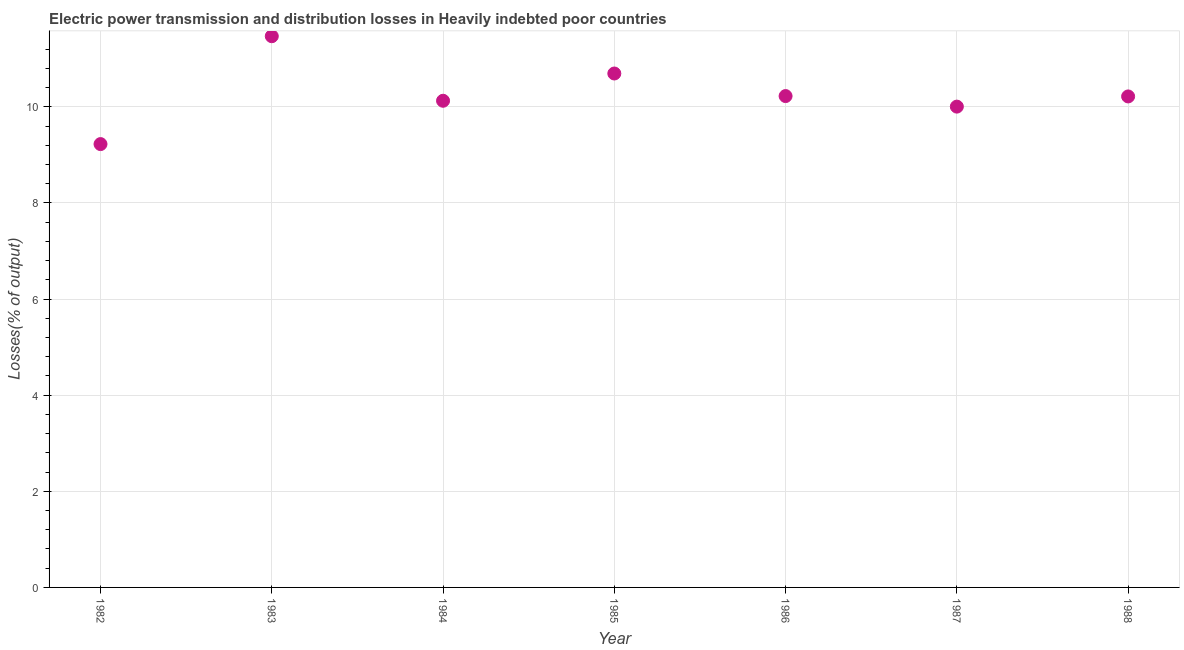What is the electric power transmission and distribution losses in 1988?
Ensure brevity in your answer.  10.22. Across all years, what is the maximum electric power transmission and distribution losses?
Your response must be concise. 11.47. Across all years, what is the minimum electric power transmission and distribution losses?
Your answer should be very brief. 9.23. In which year was the electric power transmission and distribution losses minimum?
Your answer should be compact. 1982. What is the sum of the electric power transmission and distribution losses?
Offer a very short reply. 71.96. What is the difference between the electric power transmission and distribution losses in 1986 and 1987?
Your answer should be very brief. 0.22. What is the average electric power transmission and distribution losses per year?
Offer a very short reply. 10.28. What is the median electric power transmission and distribution losses?
Your answer should be very brief. 10.22. In how many years, is the electric power transmission and distribution losses greater than 9.6 %?
Make the answer very short. 6. What is the ratio of the electric power transmission and distribution losses in 1982 to that in 1986?
Your answer should be very brief. 0.9. Is the difference between the electric power transmission and distribution losses in 1984 and 1988 greater than the difference between any two years?
Give a very brief answer. No. What is the difference between the highest and the second highest electric power transmission and distribution losses?
Provide a succinct answer. 0.78. Is the sum of the electric power transmission and distribution losses in 1983 and 1987 greater than the maximum electric power transmission and distribution losses across all years?
Offer a very short reply. Yes. What is the difference between the highest and the lowest electric power transmission and distribution losses?
Provide a succinct answer. 2.24. Does the electric power transmission and distribution losses monotonically increase over the years?
Your answer should be compact. No. How many dotlines are there?
Make the answer very short. 1. How many years are there in the graph?
Provide a succinct answer. 7. Are the values on the major ticks of Y-axis written in scientific E-notation?
Ensure brevity in your answer.  No. Does the graph contain any zero values?
Keep it short and to the point. No. Does the graph contain grids?
Your answer should be compact. Yes. What is the title of the graph?
Give a very brief answer. Electric power transmission and distribution losses in Heavily indebted poor countries. What is the label or title of the X-axis?
Give a very brief answer. Year. What is the label or title of the Y-axis?
Provide a succinct answer. Losses(% of output). What is the Losses(% of output) in 1982?
Make the answer very short. 9.23. What is the Losses(% of output) in 1983?
Offer a terse response. 11.47. What is the Losses(% of output) in 1984?
Your response must be concise. 10.13. What is the Losses(% of output) in 1985?
Ensure brevity in your answer.  10.69. What is the Losses(% of output) in 1986?
Offer a very short reply. 10.22. What is the Losses(% of output) in 1987?
Make the answer very short. 10. What is the Losses(% of output) in 1988?
Your response must be concise. 10.22. What is the difference between the Losses(% of output) in 1982 and 1983?
Provide a short and direct response. -2.24. What is the difference between the Losses(% of output) in 1982 and 1984?
Provide a short and direct response. -0.9. What is the difference between the Losses(% of output) in 1982 and 1985?
Offer a very short reply. -1.47. What is the difference between the Losses(% of output) in 1982 and 1986?
Provide a short and direct response. -1. What is the difference between the Losses(% of output) in 1982 and 1987?
Provide a short and direct response. -0.78. What is the difference between the Losses(% of output) in 1982 and 1988?
Keep it short and to the point. -0.99. What is the difference between the Losses(% of output) in 1983 and 1984?
Your answer should be very brief. 1.34. What is the difference between the Losses(% of output) in 1983 and 1985?
Give a very brief answer. 0.78. What is the difference between the Losses(% of output) in 1983 and 1986?
Provide a short and direct response. 1.25. What is the difference between the Losses(% of output) in 1983 and 1987?
Your response must be concise. 1.46. What is the difference between the Losses(% of output) in 1983 and 1988?
Your answer should be very brief. 1.25. What is the difference between the Losses(% of output) in 1984 and 1985?
Ensure brevity in your answer.  -0.57. What is the difference between the Losses(% of output) in 1984 and 1986?
Your answer should be compact. -0.1. What is the difference between the Losses(% of output) in 1984 and 1987?
Provide a succinct answer. 0.12. What is the difference between the Losses(% of output) in 1984 and 1988?
Offer a very short reply. -0.09. What is the difference between the Losses(% of output) in 1985 and 1986?
Ensure brevity in your answer.  0.47. What is the difference between the Losses(% of output) in 1985 and 1987?
Your response must be concise. 0.69. What is the difference between the Losses(% of output) in 1985 and 1988?
Make the answer very short. 0.48. What is the difference between the Losses(% of output) in 1986 and 1987?
Offer a terse response. 0.22. What is the difference between the Losses(% of output) in 1986 and 1988?
Ensure brevity in your answer.  0.01. What is the difference between the Losses(% of output) in 1987 and 1988?
Ensure brevity in your answer.  -0.21. What is the ratio of the Losses(% of output) in 1982 to that in 1983?
Offer a very short reply. 0.8. What is the ratio of the Losses(% of output) in 1982 to that in 1984?
Give a very brief answer. 0.91. What is the ratio of the Losses(% of output) in 1982 to that in 1985?
Your answer should be very brief. 0.86. What is the ratio of the Losses(% of output) in 1982 to that in 1986?
Give a very brief answer. 0.9. What is the ratio of the Losses(% of output) in 1982 to that in 1987?
Your answer should be very brief. 0.92. What is the ratio of the Losses(% of output) in 1982 to that in 1988?
Offer a very short reply. 0.9. What is the ratio of the Losses(% of output) in 1983 to that in 1984?
Keep it short and to the point. 1.13. What is the ratio of the Losses(% of output) in 1983 to that in 1985?
Your answer should be compact. 1.07. What is the ratio of the Losses(% of output) in 1983 to that in 1986?
Your answer should be compact. 1.12. What is the ratio of the Losses(% of output) in 1983 to that in 1987?
Make the answer very short. 1.15. What is the ratio of the Losses(% of output) in 1983 to that in 1988?
Your response must be concise. 1.12. What is the ratio of the Losses(% of output) in 1984 to that in 1985?
Your response must be concise. 0.95. What is the ratio of the Losses(% of output) in 1984 to that in 1988?
Your answer should be compact. 0.99. What is the ratio of the Losses(% of output) in 1985 to that in 1986?
Offer a terse response. 1.05. What is the ratio of the Losses(% of output) in 1985 to that in 1987?
Offer a very short reply. 1.07. What is the ratio of the Losses(% of output) in 1985 to that in 1988?
Keep it short and to the point. 1.05. What is the ratio of the Losses(% of output) in 1986 to that in 1987?
Provide a short and direct response. 1.02. What is the ratio of the Losses(% of output) in 1986 to that in 1988?
Give a very brief answer. 1. 